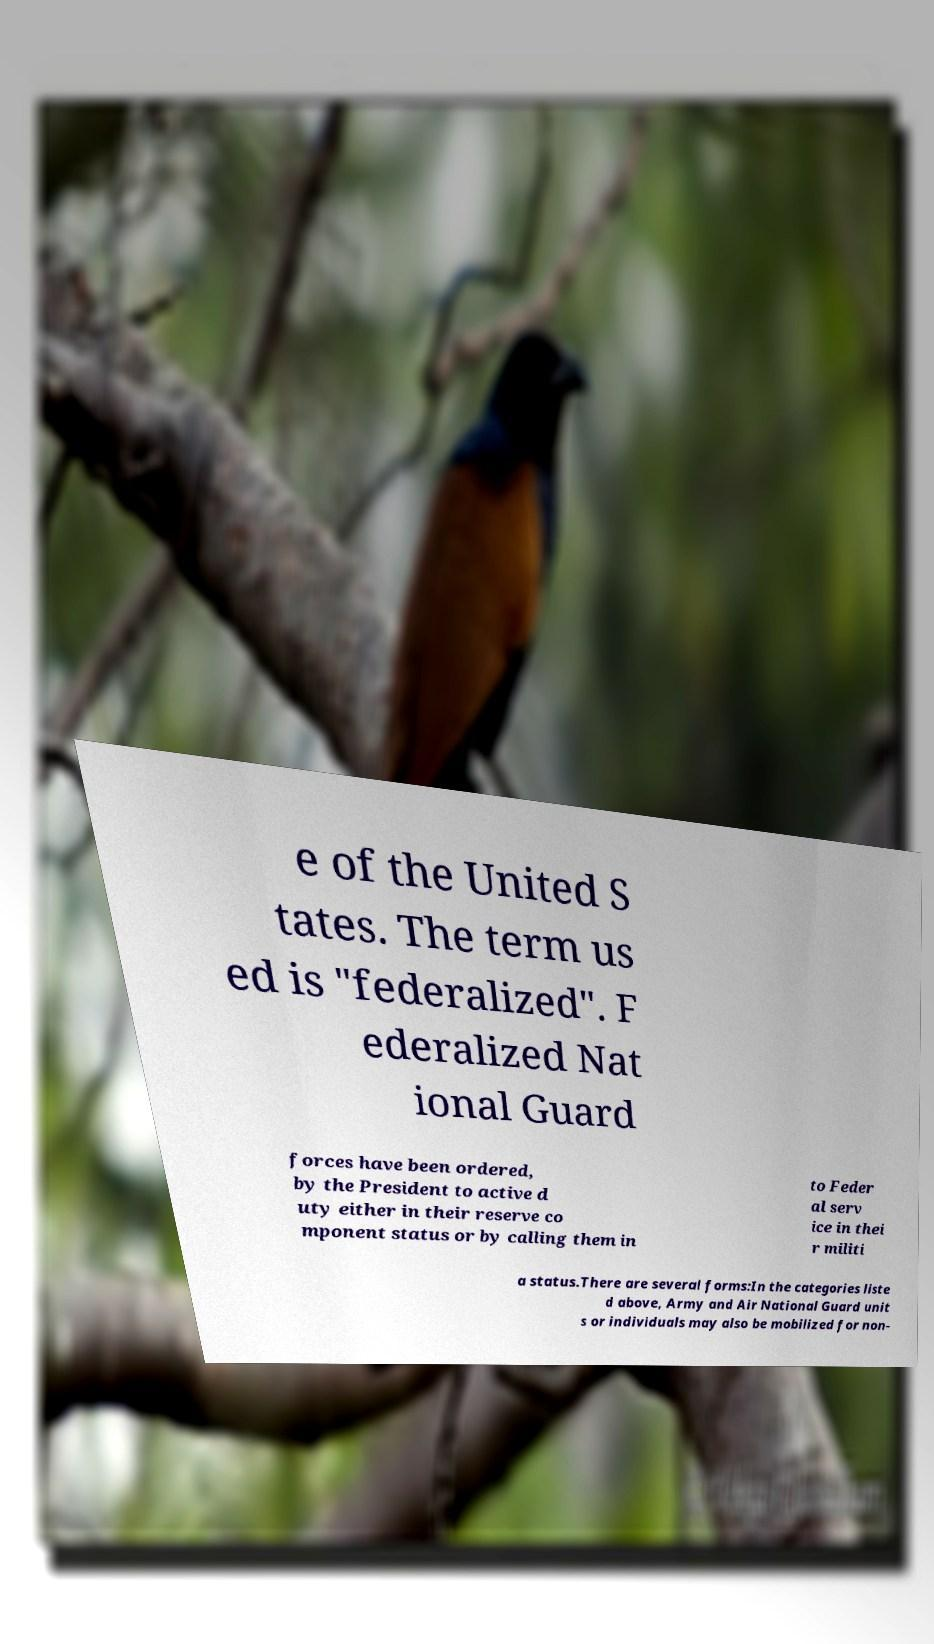What messages or text are displayed in this image? I need them in a readable, typed format. e of the United S tates. The term us ed is "federalized". F ederalized Nat ional Guard forces have been ordered, by the President to active d uty either in their reserve co mponent status or by calling them in to Feder al serv ice in thei r militi a status.There are several forms:In the categories liste d above, Army and Air National Guard unit s or individuals may also be mobilized for non- 